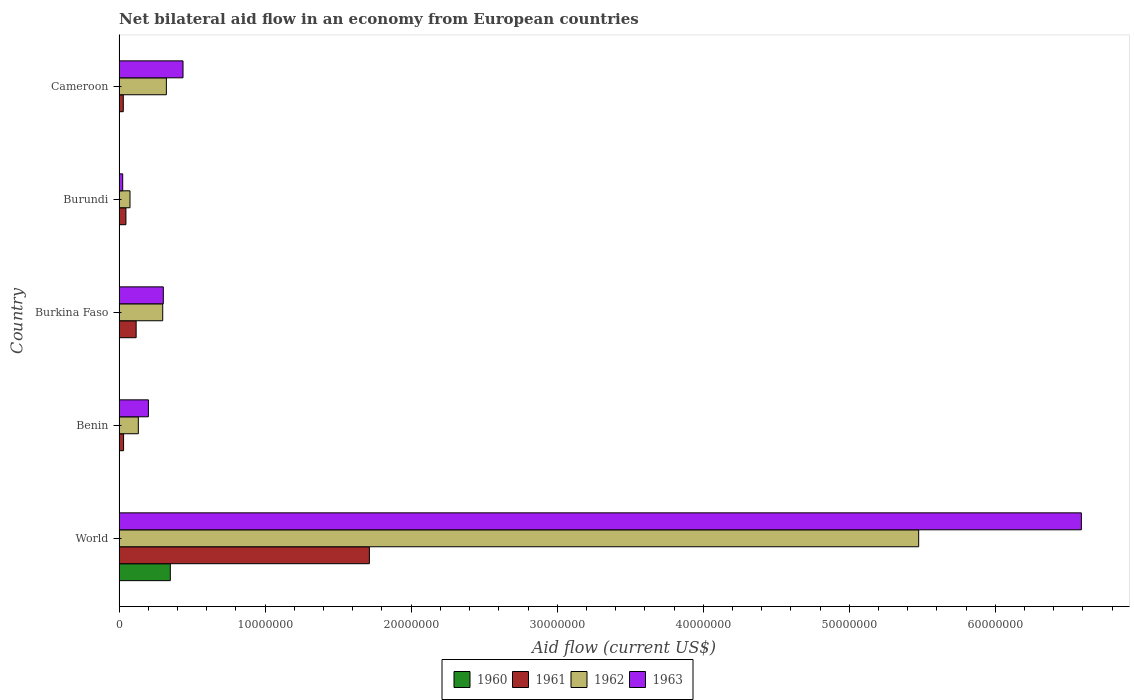How many different coloured bars are there?
Offer a terse response. 4. How many groups of bars are there?
Keep it short and to the point. 5. Are the number of bars per tick equal to the number of legend labels?
Your answer should be very brief. Yes. How many bars are there on the 2nd tick from the top?
Offer a terse response. 4. How many bars are there on the 2nd tick from the bottom?
Ensure brevity in your answer.  4. What is the label of the 4th group of bars from the top?
Provide a succinct answer. Benin. In how many cases, is the number of bars for a given country not equal to the number of legend labels?
Your response must be concise. 0. What is the net bilateral aid flow in 1963 in Burkina Faso?
Keep it short and to the point. 3.03e+06. Across all countries, what is the maximum net bilateral aid flow in 1960?
Keep it short and to the point. 3.51e+06. In which country was the net bilateral aid flow in 1961 maximum?
Provide a succinct answer. World. In which country was the net bilateral aid flow in 1963 minimum?
Give a very brief answer. Burundi. What is the total net bilateral aid flow in 1963 in the graph?
Your answer should be very brief. 7.56e+07. What is the difference between the net bilateral aid flow in 1962 in Cameroon and that in World?
Provide a succinct answer. -5.15e+07. What is the difference between the net bilateral aid flow in 1960 in Burundi and the net bilateral aid flow in 1962 in Benin?
Keep it short and to the point. -1.31e+06. What is the average net bilateral aid flow in 1960 per country?
Your answer should be very brief. 7.12e+05. What is the difference between the net bilateral aid flow in 1961 and net bilateral aid flow in 1960 in World?
Make the answer very short. 1.36e+07. What is the ratio of the net bilateral aid flow in 1961 in Burkina Faso to that in Cameroon?
Provide a succinct answer. 4.03. Is the net bilateral aid flow in 1960 in Burundi less than that in Cameroon?
Give a very brief answer. Yes. What is the difference between the highest and the second highest net bilateral aid flow in 1961?
Offer a terse response. 1.60e+07. What is the difference between the highest and the lowest net bilateral aid flow in 1963?
Your answer should be compact. 6.56e+07. Is it the case that in every country, the sum of the net bilateral aid flow in 1961 and net bilateral aid flow in 1963 is greater than the sum of net bilateral aid flow in 1960 and net bilateral aid flow in 1962?
Ensure brevity in your answer.  No. What does the 1st bar from the top in World represents?
Your response must be concise. 1963. How many countries are there in the graph?
Make the answer very short. 5. What is the difference between two consecutive major ticks on the X-axis?
Offer a very short reply. 1.00e+07. Are the values on the major ticks of X-axis written in scientific E-notation?
Ensure brevity in your answer.  No. Does the graph contain any zero values?
Keep it short and to the point. No. How many legend labels are there?
Your answer should be very brief. 4. What is the title of the graph?
Provide a short and direct response. Net bilateral aid flow in an economy from European countries. Does "2011" appear as one of the legend labels in the graph?
Your response must be concise. No. What is the label or title of the X-axis?
Offer a very short reply. Aid flow (current US$). What is the Aid flow (current US$) of 1960 in World?
Your answer should be compact. 3.51e+06. What is the Aid flow (current US$) of 1961 in World?
Provide a succinct answer. 1.71e+07. What is the Aid flow (current US$) in 1962 in World?
Make the answer very short. 5.48e+07. What is the Aid flow (current US$) in 1963 in World?
Give a very brief answer. 6.59e+07. What is the Aid flow (current US$) in 1961 in Benin?
Your response must be concise. 3.10e+05. What is the Aid flow (current US$) in 1962 in Benin?
Keep it short and to the point. 1.32e+06. What is the Aid flow (current US$) in 1963 in Benin?
Offer a very short reply. 2.01e+06. What is the Aid flow (current US$) of 1960 in Burkina Faso?
Make the answer very short. 10000. What is the Aid flow (current US$) in 1961 in Burkina Faso?
Keep it short and to the point. 1.17e+06. What is the Aid flow (current US$) in 1962 in Burkina Faso?
Your answer should be compact. 2.99e+06. What is the Aid flow (current US$) of 1963 in Burkina Faso?
Your response must be concise. 3.03e+06. What is the Aid flow (current US$) in 1960 in Burundi?
Keep it short and to the point. 10000. What is the Aid flow (current US$) in 1962 in Burundi?
Your response must be concise. 7.50e+05. What is the Aid flow (current US$) of 1960 in Cameroon?
Your answer should be very brief. 2.00e+04. What is the Aid flow (current US$) in 1962 in Cameroon?
Give a very brief answer. 3.24e+06. What is the Aid flow (current US$) of 1963 in Cameroon?
Make the answer very short. 4.38e+06. Across all countries, what is the maximum Aid flow (current US$) in 1960?
Offer a terse response. 3.51e+06. Across all countries, what is the maximum Aid flow (current US$) in 1961?
Your answer should be very brief. 1.71e+07. Across all countries, what is the maximum Aid flow (current US$) of 1962?
Provide a succinct answer. 5.48e+07. Across all countries, what is the maximum Aid flow (current US$) in 1963?
Make the answer very short. 6.59e+07. Across all countries, what is the minimum Aid flow (current US$) in 1961?
Keep it short and to the point. 2.90e+05. Across all countries, what is the minimum Aid flow (current US$) in 1962?
Provide a short and direct response. 7.50e+05. Across all countries, what is the minimum Aid flow (current US$) of 1963?
Provide a succinct answer. 2.50e+05. What is the total Aid flow (current US$) of 1960 in the graph?
Keep it short and to the point. 3.56e+06. What is the total Aid flow (current US$) of 1961 in the graph?
Offer a very short reply. 1.94e+07. What is the total Aid flow (current US$) of 1962 in the graph?
Offer a very short reply. 6.30e+07. What is the total Aid flow (current US$) of 1963 in the graph?
Keep it short and to the point. 7.56e+07. What is the difference between the Aid flow (current US$) of 1960 in World and that in Benin?
Keep it short and to the point. 3.50e+06. What is the difference between the Aid flow (current US$) in 1961 in World and that in Benin?
Keep it short and to the point. 1.68e+07. What is the difference between the Aid flow (current US$) of 1962 in World and that in Benin?
Provide a succinct answer. 5.34e+07. What is the difference between the Aid flow (current US$) of 1963 in World and that in Benin?
Provide a short and direct response. 6.39e+07. What is the difference between the Aid flow (current US$) of 1960 in World and that in Burkina Faso?
Offer a terse response. 3.50e+06. What is the difference between the Aid flow (current US$) in 1961 in World and that in Burkina Faso?
Give a very brief answer. 1.60e+07. What is the difference between the Aid flow (current US$) in 1962 in World and that in Burkina Faso?
Keep it short and to the point. 5.18e+07. What is the difference between the Aid flow (current US$) in 1963 in World and that in Burkina Faso?
Give a very brief answer. 6.29e+07. What is the difference between the Aid flow (current US$) in 1960 in World and that in Burundi?
Provide a succinct answer. 3.50e+06. What is the difference between the Aid flow (current US$) of 1961 in World and that in Burundi?
Provide a short and direct response. 1.67e+07. What is the difference between the Aid flow (current US$) in 1962 in World and that in Burundi?
Ensure brevity in your answer.  5.40e+07. What is the difference between the Aid flow (current US$) in 1963 in World and that in Burundi?
Offer a very short reply. 6.56e+07. What is the difference between the Aid flow (current US$) of 1960 in World and that in Cameroon?
Offer a terse response. 3.49e+06. What is the difference between the Aid flow (current US$) in 1961 in World and that in Cameroon?
Your answer should be very brief. 1.68e+07. What is the difference between the Aid flow (current US$) in 1962 in World and that in Cameroon?
Ensure brevity in your answer.  5.15e+07. What is the difference between the Aid flow (current US$) of 1963 in World and that in Cameroon?
Make the answer very short. 6.15e+07. What is the difference between the Aid flow (current US$) in 1961 in Benin and that in Burkina Faso?
Keep it short and to the point. -8.60e+05. What is the difference between the Aid flow (current US$) in 1962 in Benin and that in Burkina Faso?
Make the answer very short. -1.67e+06. What is the difference between the Aid flow (current US$) of 1963 in Benin and that in Burkina Faso?
Give a very brief answer. -1.02e+06. What is the difference between the Aid flow (current US$) in 1960 in Benin and that in Burundi?
Your response must be concise. 0. What is the difference between the Aid flow (current US$) of 1962 in Benin and that in Burundi?
Offer a terse response. 5.70e+05. What is the difference between the Aid flow (current US$) in 1963 in Benin and that in Burundi?
Your answer should be very brief. 1.76e+06. What is the difference between the Aid flow (current US$) of 1960 in Benin and that in Cameroon?
Offer a terse response. -10000. What is the difference between the Aid flow (current US$) of 1962 in Benin and that in Cameroon?
Keep it short and to the point. -1.92e+06. What is the difference between the Aid flow (current US$) in 1963 in Benin and that in Cameroon?
Provide a succinct answer. -2.37e+06. What is the difference between the Aid flow (current US$) in 1961 in Burkina Faso and that in Burundi?
Provide a succinct answer. 7.00e+05. What is the difference between the Aid flow (current US$) in 1962 in Burkina Faso and that in Burundi?
Your response must be concise. 2.24e+06. What is the difference between the Aid flow (current US$) in 1963 in Burkina Faso and that in Burundi?
Provide a succinct answer. 2.78e+06. What is the difference between the Aid flow (current US$) in 1961 in Burkina Faso and that in Cameroon?
Keep it short and to the point. 8.80e+05. What is the difference between the Aid flow (current US$) of 1962 in Burkina Faso and that in Cameroon?
Make the answer very short. -2.50e+05. What is the difference between the Aid flow (current US$) in 1963 in Burkina Faso and that in Cameroon?
Give a very brief answer. -1.35e+06. What is the difference between the Aid flow (current US$) in 1962 in Burundi and that in Cameroon?
Offer a very short reply. -2.49e+06. What is the difference between the Aid flow (current US$) of 1963 in Burundi and that in Cameroon?
Offer a terse response. -4.13e+06. What is the difference between the Aid flow (current US$) of 1960 in World and the Aid flow (current US$) of 1961 in Benin?
Your response must be concise. 3.20e+06. What is the difference between the Aid flow (current US$) in 1960 in World and the Aid flow (current US$) in 1962 in Benin?
Provide a short and direct response. 2.19e+06. What is the difference between the Aid flow (current US$) of 1960 in World and the Aid flow (current US$) of 1963 in Benin?
Provide a succinct answer. 1.50e+06. What is the difference between the Aid flow (current US$) in 1961 in World and the Aid flow (current US$) in 1962 in Benin?
Your response must be concise. 1.58e+07. What is the difference between the Aid flow (current US$) of 1961 in World and the Aid flow (current US$) of 1963 in Benin?
Your response must be concise. 1.51e+07. What is the difference between the Aid flow (current US$) of 1962 in World and the Aid flow (current US$) of 1963 in Benin?
Your answer should be compact. 5.27e+07. What is the difference between the Aid flow (current US$) in 1960 in World and the Aid flow (current US$) in 1961 in Burkina Faso?
Provide a succinct answer. 2.34e+06. What is the difference between the Aid flow (current US$) in 1960 in World and the Aid flow (current US$) in 1962 in Burkina Faso?
Make the answer very short. 5.20e+05. What is the difference between the Aid flow (current US$) in 1961 in World and the Aid flow (current US$) in 1962 in Burkina Faso?
Provide a short and direct response. 1.42e+07. What is the difference between the Aid flow (current US$) of 1961 in World and the Aid flow (current US$) of 1963 in Burkina Faso?
Offer a terse response. 1.41e+07. What is the difference between the Aid flow (current US$) in 1962 in World and the Aid flow (current US$) in 1963 in Burkina Faso?
Your response must be concise. 5.17e+07. What is the difference between the Aid flow (current US$) of 1960 in World and the Aid flow (current US$) of 1961 in Burundi?
Give a very brief answer. 3.04e+06. What is the difference between the Aid flow (current US$) of 1960 in World and the Aid flow (current US$) of 1962 in Burundi?
Your response must be concise. 2.76e+06. What is the difference between the Aid flow (current US$) of 1960 in World and the Aid flow (current US$) of 1963 in Burundi?
Keep it short and to the point. 3.26e+06. What is the difference between the Aid flow (current US$) in 1961 in World and the Aid flow (current US$) in 1962 in Burundi?
Offer a very short reply. 1.64e+07. What is the difference between the Aid flow (current US$) of 1961 in World and the Aid flow (current US$) of 1963 in Burundi?
Your response must be concise. 1.69e+07. What is the difference between the Aid flow (current US$) in 1962 in World and the Aid flow (current US$) in 1963 in Burundi?
Provide a short and direct response. 5.45e+07. What is the difference between the Aid flow (current US$) in 1960 in World and the Aid flow (current US$) in 1961 in Cameroon?
Provide a short and direct response. 3.22e+06. What is the difference between the Aid flow (current US$) of 1960 in World and the Aid flow (current US$) of 1962 in Cameroon?
Ensure brevity in your answer.  2.70e+05. What is the difference between the Aid flow (current US$) of 1960 in World and the Aid flow (current US$) of 1963 in Cameroon?
Provide a short and direct response. -8.70e+05. What is the difference between the Aid flow (current US$) of 1961 in World and the Aid flow (current US$) of 1962 in Cameroon?
Make the answer very short. 1.39e+07. What is the difference between the Aid flow (current US$) in 1961 in World and the Aid flow (current US$) in 1963 in Cameroon?
Your response must be concise. 1.28e+07. What is the difference between the Aid flow (current US$) of 1962 in World and the Aid flow (current US$) of 1963 in Cameroon?
Provide a succinct answer. 5.04e+07. What is the difference between the Aid flow (current US$) of 1960 in Benin and the Aid flow (current US$) of 1961 in Burkina Faso?
Ensure brevity in your answer.  -1.16e+06. What is the difference between the Aid flow (current US$) of 1960 in Benin and the Aid flow (current US$) of 1962 in Burkina Faso?
Offer a terse response. -2.98e+06. What is the difference between the Aid flow (current US$) of 1960 in Benin and the Aid flow (current US$) of 1963 in Burkina Faso?
Give a very brief answer. -3.02e+06. What is the difference between the Aid flow (current US$) of 1961 in Benin and the Aid flow (current US$) of 1962 in Burkina Faso?
Your answer should be very brief. -2.68e+06. What is the difference between the Aid flow (current US$) of 1961 in Benin and the Aid flow (current US$) of 1963 in Burkina Faso?
Provide a succinct answer. -2.72e+06. What is the difference between the Aid flow (current US$) of 1962 in Benin and the Aid flow (current US$) of 1963 in Burkina Faso?
Make the answer very short. -1.71e+06. What is the difference between the Aid flow (current US$) in 1960 in Benin and the Aid flow (current US$) in 1961 in Burundi?
Give a very brief answer. -4.60e+05. What is the difference between the Aid flow (current US$) of 1960 in Benin and the Aid flow (current US$) of 1962 in Burundi?
Ensure brevity in your answer.  -7.40e+05. What is the difference between the Aid flow (current US$) of 1960 in Benin and the Aid flow (current US$) of 1963 in Burundi?
Keep it short and to the point. -2.40e+05. What is the difference between the Aid flow (current US$) in 1961 in Benin and the Aid flow (current US$) in 1962 in Burundi?
Provide a short and direct response. -4.40e+05. What is the difference between the Aid flow (current US$) in 1961 in Benin and the Aid flow (current US$) in 1963 in Burundi?
Make the answer very short. 6.00e+04. What is the difference between the Aid flow (current US$) in 1962 in Benin and the Aid flow (current US$) in 1963 in Burundi?
Make the answer very short. 1.07e+06. What is the difference between the Aid flow (current US$) in 1960 in Benin and the Aid flow (current US$) in 1961 in Cameroon?
Make the answer very short. -2.80e+05. What is the difference between the Aid flow (current US$) of 1960 in Benin and the Aid flow (current US$) of 1962 in Cameroon?
Give a very brief answer. -3.23e+06. What is the difference between the Aid flow (current US$) of 1960 in Benin and the Aid flow (current US$) of 1963 in Cameroon?
Your answer should be very brief. -4.37e+06. What is the difference between the Aid flow (current US$) in 1961 in Benin and the Aid flow (current US$) in 1962 in Cameroon?
Give a very brief answer. -2.93e+06. What is the difference between the Aid flow (current US$) in 1961 in Benin and the Aid flow (current US$) in 1963 in Cameroon?
Make the answer very short. -4.07e+06. What is the difference between the Aid flow (current US$) of 1962 in Benin and the Aid flow (current US$) of 1963 in Cameroon?
Offer a very short reply. -3.06e+06. What is the difference between the Aid flow (current US$) of 1960 in Burkina Faso and the Aid flow (current US$) of 1961 in Burundi?
Ensure brevity in your answer.  -4.60e+05. What is the difference between the Aid flow (current US$) in 1960 in Burkina Faso and the Aid flow (current US$) in 1962 in Burundi?
Keep it short and to the point. -7.40e+05. What is the difference between the Aid flow (current US$) in 1961 in Burkina Faso and the Aid flow (current US$) in 1962 in Burundi?
Give a very brief answer. 4.20e+05. What is the difference between the Aid flow (current US$) in 1961 in Burkina Faso and the Aid flow (current US$) in 1963 in Burundi?
Your answer should be very brief. 9.20e+05. What is the difference between the Aid flow (current US$) in 1962 in Burkina Faso and the Aid flow (current US$) in 1963 in Burundi?
Give a very brief answer. 2.74e+06. What is the difference between the Aid flow (current US$) of 1960 in Burkina Faso and the Aid flow (current US$) of 1961 in Cameroon?
Ensure brevity in your answer.  -2.80e+05. What is the difference between the Aid flow (current US$) in 1960 in Burkina Faso and the Aid flow (current US$) in 1962 in Cameroon?
Provide a short and direct response. -3.23e+06. What is the difference between the Aid flow (current US$) of 1960 in Burkina Faso and the Aid flow (current US$) of 1963 in Cameroon?
Offer a terse response. -4.37e+06. What is the difference between the Aid flow (current US$) of 1961 in Burkina Faso and the Aid flow (current US$) of 1962 in Cameroon?
Offer a very short reply. -2.07e+06. What is the difference between the Aid flow (current US$) in 1961 in Burkina Faso and the Aid flow (current US$) in 1963 in Cameroon?
Give a very brief answer. -3.21e+06. What is the difference between the Aid flow (current US$) in 1962 in Burkina Faso and the Aid flow (current US$) in 1963 in Cameroon?
Offer a terse response. -1.39e+06. What is the difference between the Aid flow (current US$) of 1960 in Burundi and the Aid flow (current US$) of 1961 in Cameroon?
Provide a succinct answer. -2.80e+05. What is the difference between the Aid flow (current US$) in 1960 in Burundi and the Aid flow (current US$) in 1962 in Cameroon?
Keep it short and to the point. -3.23e+06. What is the difference between the Aid flow (current US$) of 1960 in Burundi and the Aid flow (current US$) of 1963 in Cameroon?
Your answer should be very brief. -4.37e+06. What is the difference between the Aid flow (current US$) of 1961 in Burundi and the Aid flow (current US$) of 1962 in Cameroon?
Provide a succinct answer. -2.77e+06. What is the difference between the Aid flow (current US$) in 1961 in Burundi and the Aid flow (current US$) in 1963 in Cameroon?
Your answer should be compact. -3.91e+06. What is the difference between the Aid flow (current US$) in 1962 in Burundi and the Aid flow (current US$) in 1963 in Cameroon?
Give a very brief answer. -3.63e+06. What is the average Aid flow (current US$) in 1960 per country?
Your response must be concise. 7.12e+05. What is the average Aid flow (current US$) of 1961 per country?
Give a very brief answer. 3.88e+06. What is the average Aid flow (current US$) in 1962 per country?
Your response must be concise. 1.26e+07. What is the average Aid flow (current US$) of 1963 per country?
Your response must be concise. 1.51e+07. What is the difference between the Aid flow (current US$) of 1960 and Aid flow (current US$) of 1961 in World?
Give a very brief answer. -1.36e+07. What is the difference between the Aid flow (current US$) of 1960 and Aid flow (current US$) of 1962 in World?
Your answer should be compact. -5.12e+07. What is the difference between the Aid flow (current US$) of 1960 and Aid flow (current US$) of 1963 in World?
Offer a terse response. -6.24e+07. What is the difference between the Aid flow (current US$) in 1961 and Aid flow (current US$) in 1962 in World?
Your answer should be very brief. -3.76e+07. What is the difference between the Aid flow (current US$) in 1961 and Aid flow (current US$) in 1963 in World?
Ensure brevity in your answer.  -4.88e+07. What is the difference between the Aid flow (current US$) in 1962 and Aid flow (current US$) in 1963 in World?
Your answer should be compact. -1.11e+07. What is the difference between the Aid flow (current US$) of 1960 and Aid flow (current US$) of 1961 in Benin?
Provide a short and direct response. -3.00e+05. What is the difference between the Aid flow (current US$) of 1960 and Aid flow (current US$) of 1962 in Benin?
Offer a very short reply. -1.31e+06. What is the difference between the Aid flow (current US$) of 1961 and Aid flow (current US$) of 1962 in Benin?
Your response must be concise. -1.01e+06. What is the difference between the Aid flow (current US$) in 1961 and Aid flow (current US$) in 1963 in Benin?
Your answer should be very brief. -1.70e+06. What is the difference between the Aid flow (current US$) of 1962 and Aid flow (current US$) of 1963 in Benin?
Provide a short and direct response. -6.90e+05. What is the difference between the Aid flow (current US$) of 1960 and Aid flow (current US$) of 1961 in Burkina Faso?
Keep it short and to the point. -1.16e+06. What is the difference between the Aid flow (current US$) in 1960 and Aid flow (current US$) in 1962 in Burkina Faso?
Your answer should be compact. -2.98e+06. What is the difference between the Aid flow (current US$) in 1960 and Aid flow (current US$) in 1963 in Burkina Faso?
Give a very brief answer. -3.02e+06. What is the difference between the Aid flow (current US$) of 1961 and Aid flow (current US$) of 1962 in Burkina Faso?
Your answer should be compact. -1.82e+06. What is the difference between the Aid flow (current US$) in 1961 and Aid flow (current US$) in 1963 in Burkina Faso?
Offer a terse response. -1.86e+06. What is the difference between the Aid flow (current US$) of 1960 and Aid flow (current US$) of 1961 in Burundi?
Keep it short and to the point. -4.60e+05. What is the difference between the Aid flow (current US$) in 1960 and Aid flow (current US$) in 1962 in Burundi?
Give a very brief answer. -7.40e+05. What is the difference between the Aid flow (current US$) of 1961 and Aid flow (current US$) of 1962 in Burundi?
Provide a short and direct response. -2.80e+05. What is the difference between the Aid flow (current US$) of 1961 and Aid flow (current US$) of 1963 in Burundi?
Give a very brief answer. 2.20e+05. What is the difference between the Aid flow (current US$) in 1960 and Aid flow (current US$) in 1962 in Cameroon?
Keep it short and to the point. -3.22e+06. What is the difference between the Aid flow (current US$) of 1960 and Aid flow (current US$) of 1963 in Cameroon?
Provide a short and direct response. -4.36e+06. What is the difference between the Aid flow (current US$) in 1961 and Aid flow (current US$) in 1962 in Cameroon?
Keep it short and to the point. -2.95e+06. What is the difference between the Aid flow (current US$) of 1961 and Aid flow (current US$) of 1963 in Cameroon?
Your answer should be very brief. -4.09e+06. What is the difference between the Aid flow (current US$) in 1962 and Aid flow (current US$) in 1963 in Cameroon?
Offer a very short reply. -1.14e+06. What is the ratio of the Aid flow (current US$) in 1960 in World to that in Benin?
Provide a short and direct response. 351. What is the ratio of the Aid flow (current US$) in 1961 in World to that in Benin?
Offer a terse response. 55.29. What is the ratio of the Aid flow (current US$) of 1962 in World to that in Benin?
Keep it short and to the point. 41.48. What is the ratio of the Aid flow (current US$) of 1963 in World to that in Benin?
Ensure brevity in your answer.  32.78. What is the ratio of the Aid flow (current US$) of 1960 in World to that in Burkina Faso?
Offer a terse response. 351. What is the ratio of the Aid flow (current US$) of 1961 in World to that in Burkina Faso?
Make the answer very short. 14.65. What is the ratio of the Aid flow (current US$) in 1962 in World to that in Burkina Faso?
Your answer should be compact. 18.31. What is the ratio of the Aid flow (current US$) of 1963 in World to that in Burkina Faso?
Provide a succinct answer. 21.75. What is the ratio of the Aid flow (current US$) in 1960 in World to that in Burundi?
Your response must be concise. 351. What is the ratio of the Aid flow (current US$) of 1961 in World to that in Burundi?
Keep it short and to the point. 36.47. What is the ratio of the Aid flow (current US$) in 1962 in World to that in Burundi?
Keep it short and to the point. 73. What is the ratio of the Aid flow (current US$) of 1963 in World to that in Burundi?
Provide a succinct answer. 263.56. What is the ratio of the Aid flow (current US$) in 1960 in World to that in Cameroon?
Ensure brevity in your answer.  175.5. What is the ratio of the Aid flow (current US$) of 1961 in World to that in Cameroon?
Your response must be concise. 59.1. What is the ratio of the Aid flow (current US$) in 1962 in World to that in Cameroon?
Offer a very short reply. 16.9. What is the ratio of the Aid flow (current US$) in 1963 in World to that in Cameroon?
Your response must be concise. 15.04. What is the ratio of the Aid flow (current US$) of 1960 in Benin to that in Burkina Faso?
Your answer should be very brief. 1. What is the ratio of the Aid flow (current US$) of 1961 in Benin to that in Burkina Faso?
Your answer should be very brief. 0.27. What is the ratio of the Aid flow (current US$) of 1962 in Benin to that in Burkina Faso?
Give a very brief answer. 0.44. What is the ratio of the Aid flow (current US$) of 1963 in Benin to that in Burkina Faso?
Your response must be concise. 0.66. What is the ratio of the Aid flow (current US$) in 1960 in Benin to that in Burundi?
Ensure brevity in your answer.  1. What is the ratio of the Aid flow (current US$) in 1961 in Benin to that in Burundi?
Offer a very short reply. 0.66. What is the ratio of the Aid flow (current US$) in 1962 in Benin to that in Burundi?
Your answer should be compact. 1.76. What is the ratio of the Aid flow (current US$) in 1963 in Benin to that in Burundi?
Give a very brief answer. 8.04. What is the ratio of the Aid flow (current US$) of 1960 in Benin to that in Cameroon?
Offer a terse response. 0.5. What is the ratio of the Aid flow (current US$) in 1961 in Benin to that in Cameroon?
Offer a very short reply. 1.07. What is the ratio of the Aid flow (current US$) of 1962 in Benin to that in Cameroon?
Give a very brief answer. 0.41. What is the ratio of the Aid flow (current US$) of 1963 in Benin to that in Cameroon?
Provide a succinct answer. 0.46. What is the ratio of the Aid flow (current US$) of 1961 in Burkina Faso to that in Burundi?
Ensure brevity in your answer.  2.49. What is the ratio of the Aid flow (current US$) in 1962 in Burkina Faso to that in Burundi?
Provide a succinct answer. 3.99. What is the ratio of the Aid flow (current US$) of 1963 in Burkina Faso to that in Burundi?
Give a very brief answer. 12.12. What is the ratio of the Aid flow (current US$) in 1961 in Burkina Faso to that in Cameroon?
Keep it short and to the point. 4.03. What is the ratio of the Aid flow (current US$) in 1962 in Burkina Faso to that in Cameroon?
Your answer should be compact. 0.92. What is the ratio of the Aid flow (current US$) of 1963 in Burkina Faso to that in Cameroon?
Offer a very short reply. 0.69. What is the ratio of the Aid flow (current US$) in 1961 in Burundi to that in Cameroon?
Provide a succinct answer. 1.62. What is the ratio of the Aid flow (current US$) of 1962 in Burundi to that in Cameroon?
Your answer should be very brief. 0.23. What is the ratio of the Aid flow (current US$) of 1963 in Burundi to that in Cameroon?
Offer a terse response. 0.06. What is the difference between the highest and the second highest Aid flow (current US$) in 1960?
Give a very brief answer. 3.49e+06. What is the difference between the highest and the second highest Aid flow (current US$) of 1961?
Offer a terse response. 1.60e+07. What is the difference between the highest and the second highest Aid flow (current US$) of 1962?
Your answer should be very brief. 5.15e+07. What is the difference between the highest and the second highest Aid flow (current US$) in 1963?
Keep it short and to the point. 6.15e+07. What is the difference between the highest and the lowest Aid flow (current US$) of 1960?
Offer a very short reply. 3.50e+06. What is the difference between the highest and the lowest Aid flow (current US$) in 1961?
Provide a short and direct response. 1.68e+07. What is the difference between the highest and the lowest Aid flow (current US$) of 1962?
Your answer should be compact. 5.40e+07. What is the difference between the highest and the lowest Aid flow (current US$) of 1963?
Offer a very short reply. 6.56e+07. 